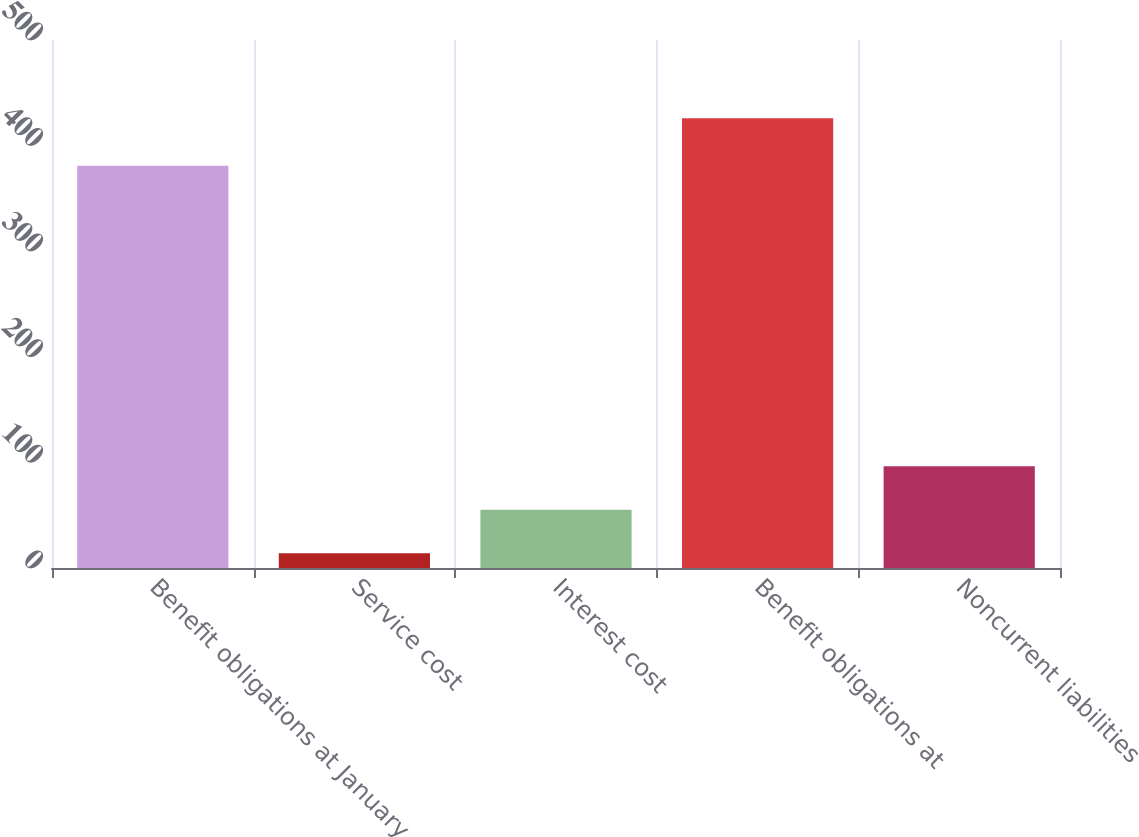Convert chart. <chart><loc_0><loc_0><loc_500><loc_500><bar_chart><fcel>Benefit obligations at January<fcel>Service cost<fcel>Interest cost<fcel>Benefit obligations at<fcel>Noncurrent liabilities<nl><fcel>381<fcel>14<fcel>55.2<fcel>426<fcel>96.4<nl></chart> 